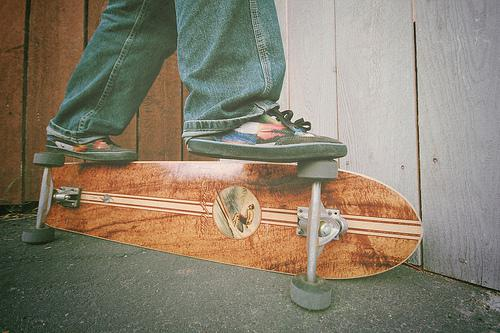Question: where was this picture taken?
Choices:
A. On the sidewalk.
B. At a football game.
C. At a zoo.
D. At the beach.
Answer with the letter. Answer: A 